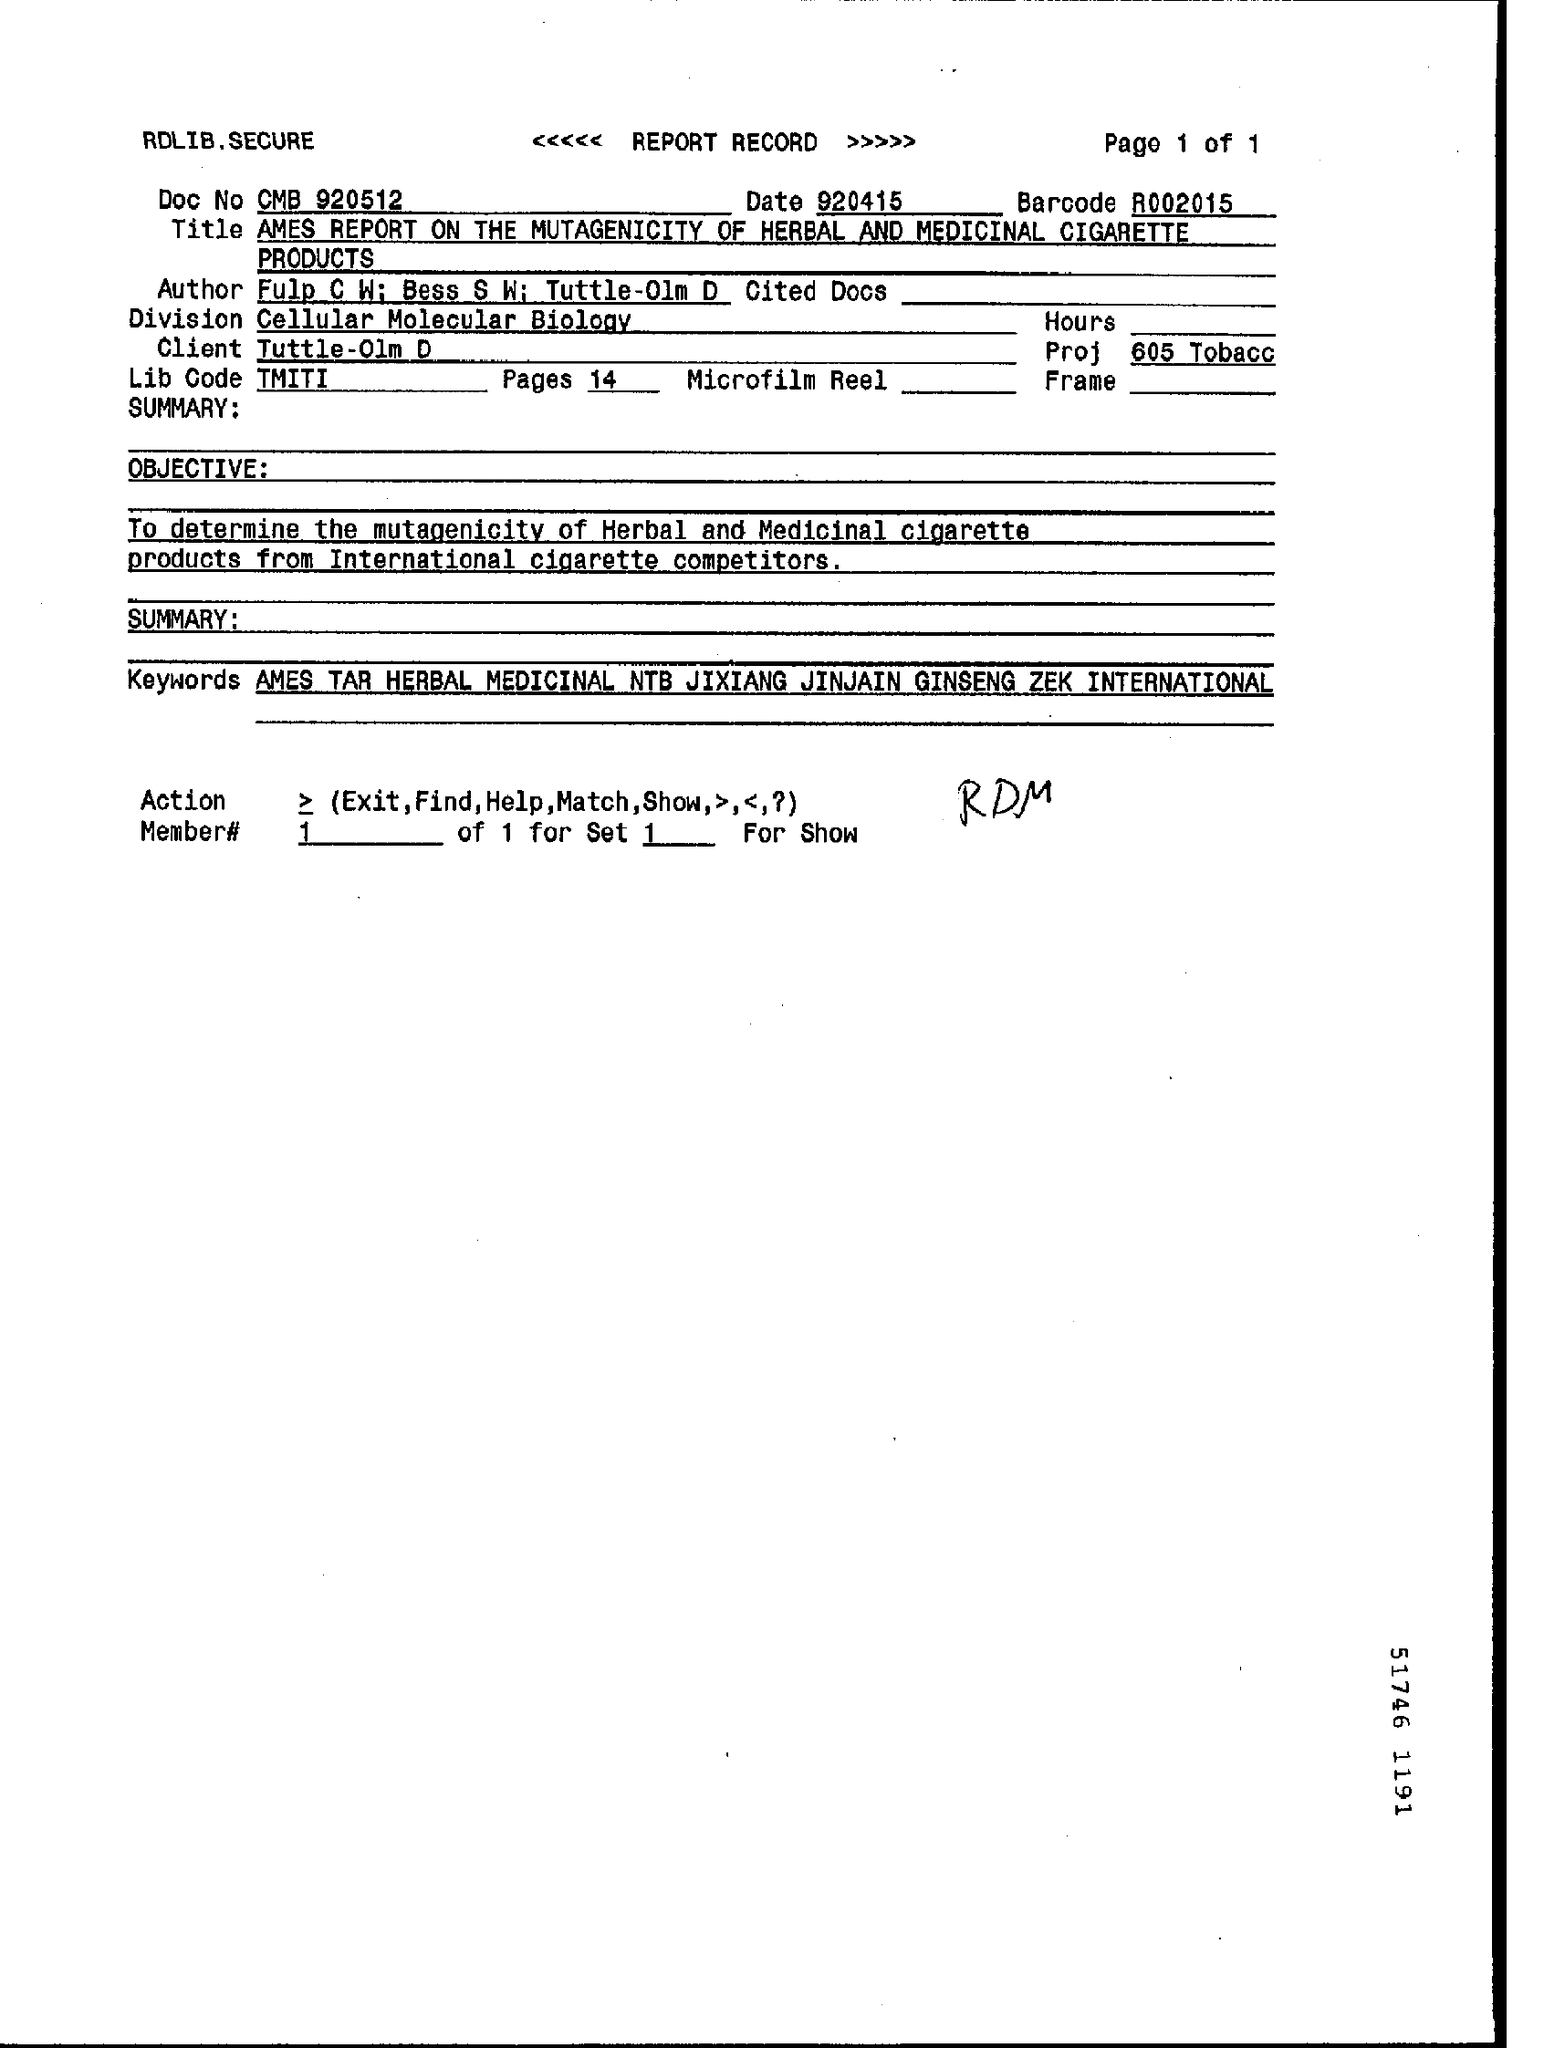List a handful of essential elements in this visual. There are 14 pages in total. 